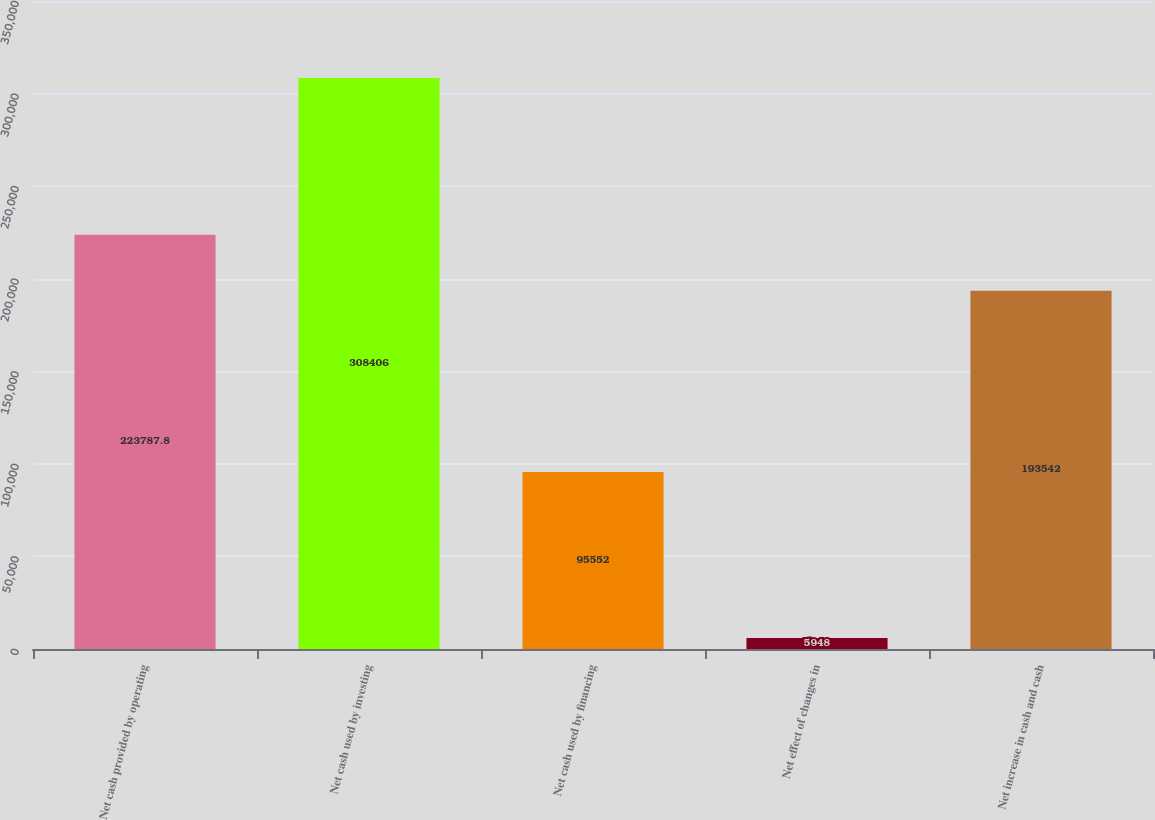<chart> <loc_0><loc_0><loc_500><loc_500><bar_chart><fcel>Net cash provided by operating<fcel>Net cash used by investing<fcel>Net cash used by financing<fcel>Net effect of changes in<fcel>Net increase in cash and cash<nl><fcel>223788<fcel>308406<fcel>95552<fcel>5948<fcel>193542<nl></chart> 